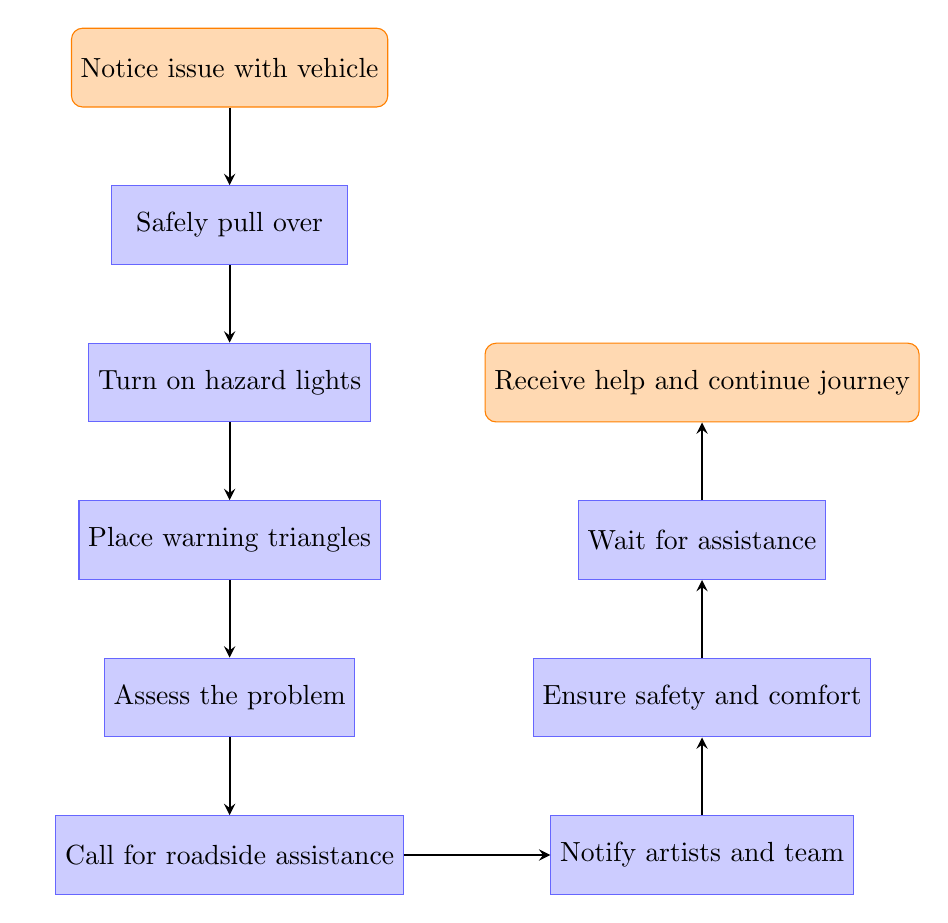What is the first step in handling a vehicle breakdown? The diagram starts with the action "Notice issue with vehicle," indicating that recognizing the problem is the initial step before any actions can be taken.
Answer: Notice issue with vehicle How many nodes are in the flowchart? The flowchart contains a total of 9 nodes, which include the start and end nodes along with the steps in between.
Answer: 9 What action follows "Turn on hazard lights"? After "Turn on hazard lights," the next action is "Place warning triangles," indicating the sequence of steps to follow for safety.
Answer: Place warning triangles What is the last action before receiving help? The final action before "Receive help and continue journey" is "Wait for assistance," meaning this is the step taken just before help arrives.
Answer: Wait for assistance Which action requires notifying other people about the breakdown? The action that involves notifying others is "Notify artists and team," which is critical for keeping everyone informed of the situation.
Answer: Notify artists and team What action must be taken immediately after pulling over safely? After "Safely pull over," the next action that must be taken is "Turn on hazard lights," emphasizing the importance of alerting other drivers on the road.
Answer: Turn on hazard lights How are the warning triangles related to safety? The action "Place warning triangles" is directly connected to enhancing safety, as these triangles serve as warnings for oncoming traffic and help prevent accidents.
Answer: Enhancing safety What is the relationship between "Call for roadside assistance" and keeping passengers informed? "Call for roadside assistance" and "Notify artists and team" are parallel steps, where both address immediate concerns: securing aid and ensuring passengers are informed.
Answer: Parallel steps Which step addresses passenger safety directly? The step titled "Ensure safety and comfort of the passengers" specifically deals with the well-being and safety of those within the vehicle during the breakdown.
Answer: Ensure safety and comfort of the passengers 